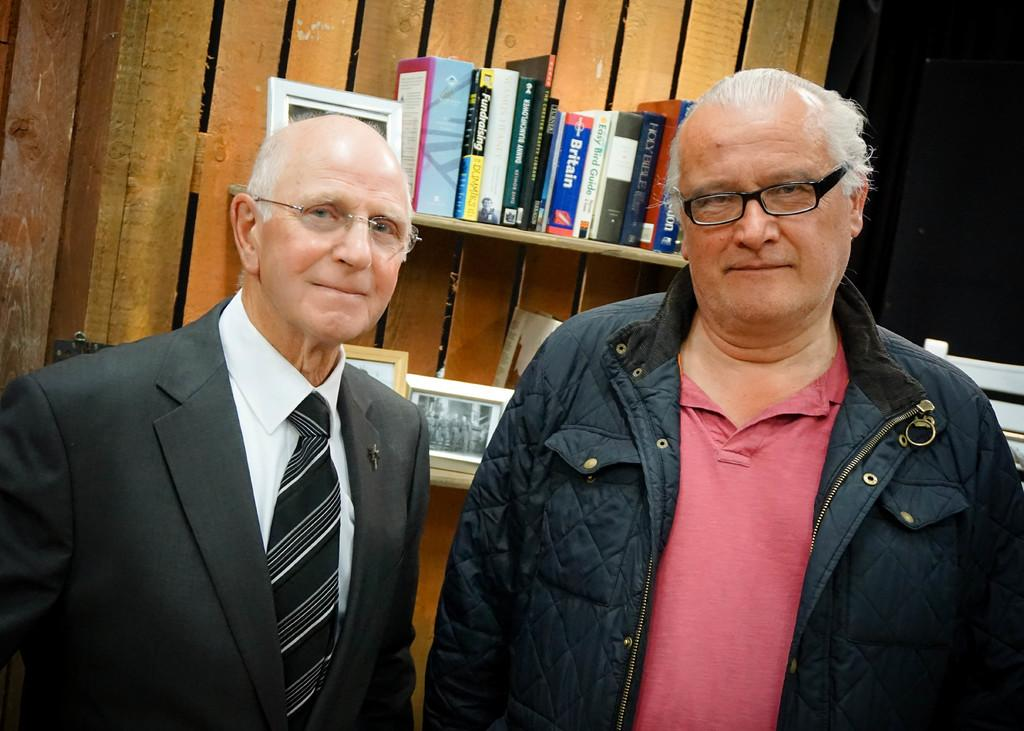What is the main subject of the image? There is a man standing in the image. What can be seen in the background of the image? There are books and frames placed on racks in the background of the image. What color is the cannon in the image? There is no cannon present in the image. How much powder is needed to fill the frames in the image? There is no mention of powder or filling frames in the image; the frames are simply placed on racks. 